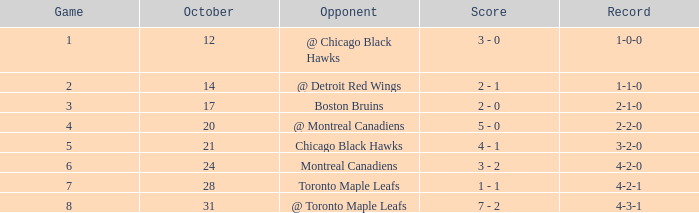What was the record for the game before game 6 against the chicago black hawks? 3-2-0. 